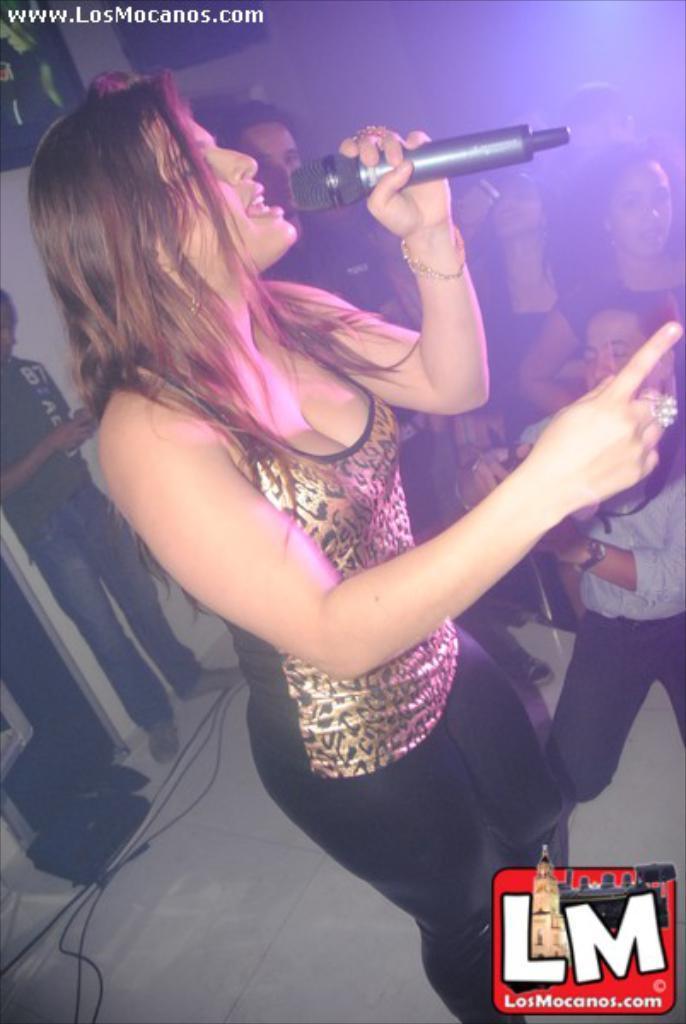Can you describe this image briefly? In this image there are group of people. There is a woman standing and singing and she is holding a microphone. At the bottom there are wires and at the back there are people holding camera and phone. 